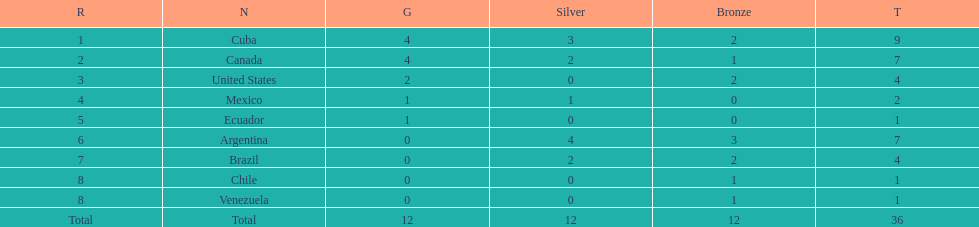How many total medals were there all together? 36. 